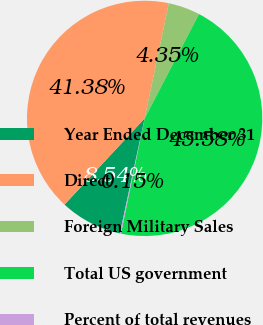<chart> <loc_0><loc_0><loc_500><loc_500><pie_chart><fcel>Year Ended December 31<fcel>Direct<fcel>Foreign Military Sales<fcel>Total US government<fcel>Percent of total revenues<nl><fcel>8.54%<fcel>41.38%<fcel>4.35%<fcel>45.58%<fcel>0.15%<nl></chart> 